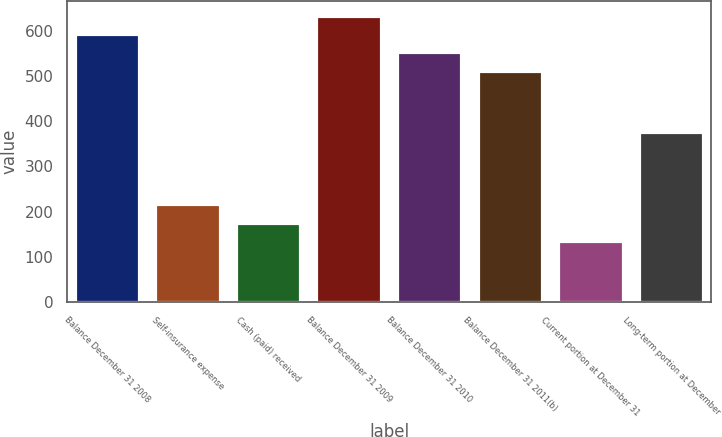Convert chart to OTSL. <chart><loc_0><loc_0><loc_500><loc_500><bar_chart><fcel>Balance December 31 2008<fcel>Self-insurance expense<fcel>Cash (paid) received<fcel>Balance December 31 2009<fcel>Balance December 31 2010<fcel>Balance December 31 2011(b)<fcel>Current portion at December 31<fcel>Long-term portion at December<nl><fcel>592.2<fcel>216.2<fcel>175.6<fcel>632.8<fcel>551.6<fcel>511<fcel>135<fcel>376<nl></chart> 